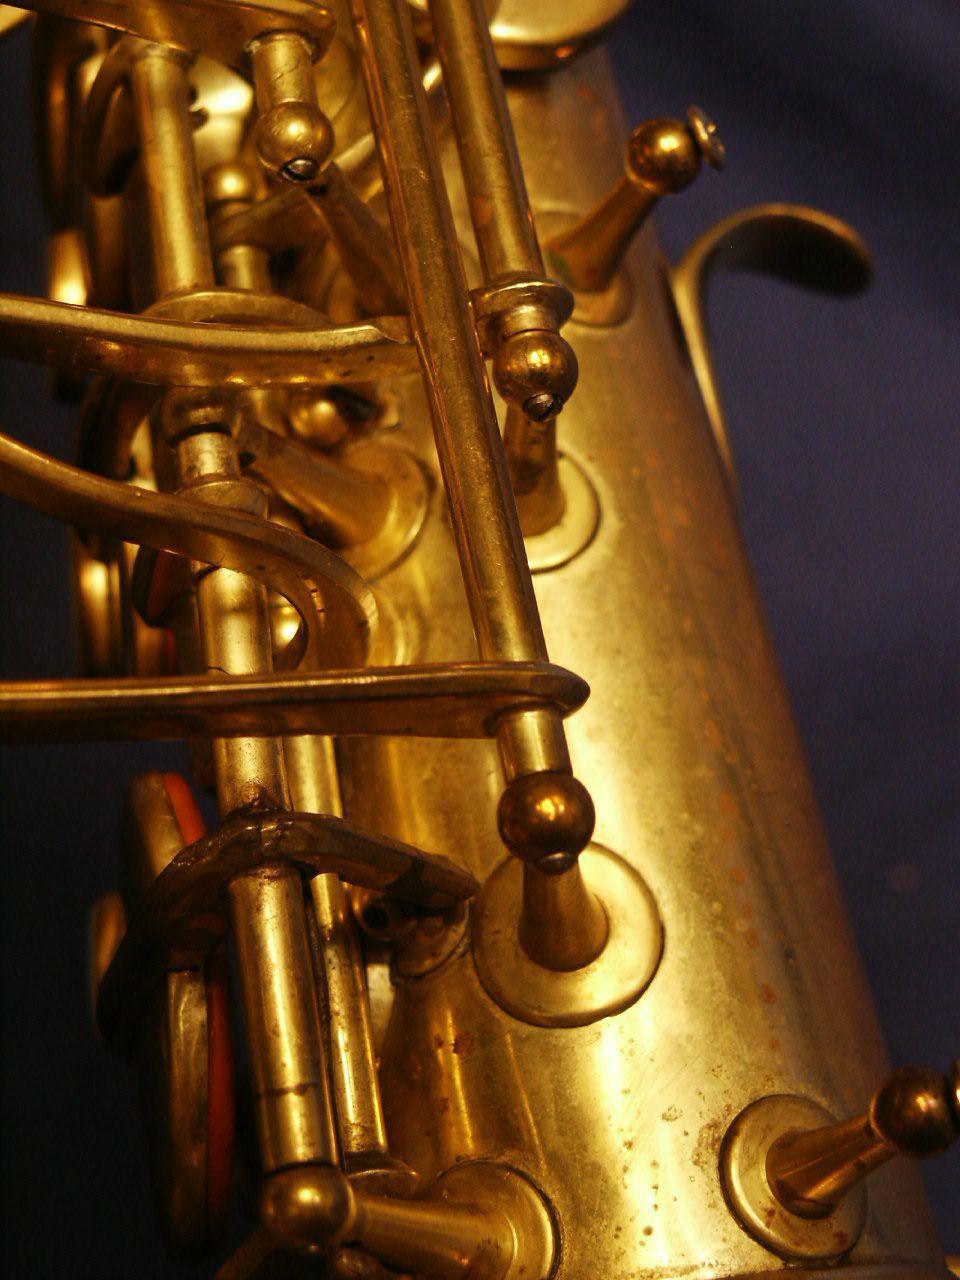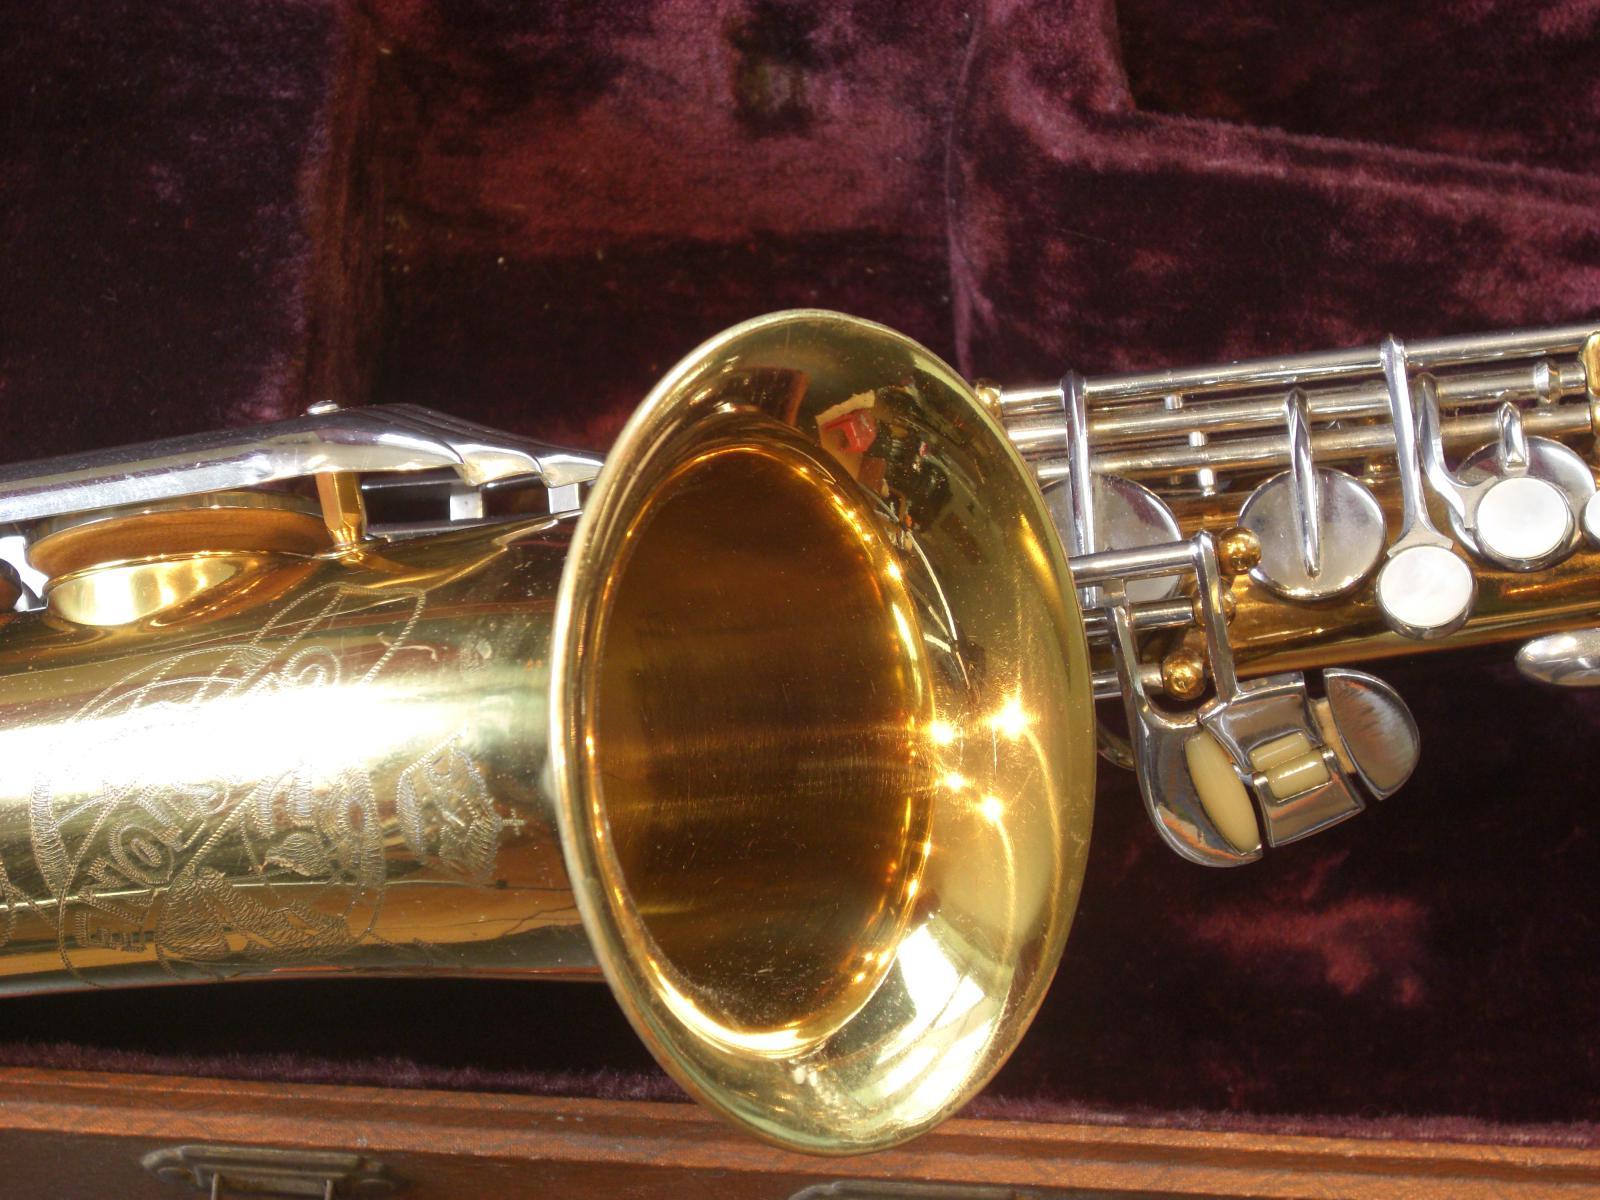The first image is the image on the left, the second image is the image on the right. Assess this claim about the two images: "One image shows the etched bell of a gold saxophone, which is displayed on burgundy fabric.". Correct or not? Answer yes or no. Yes. 